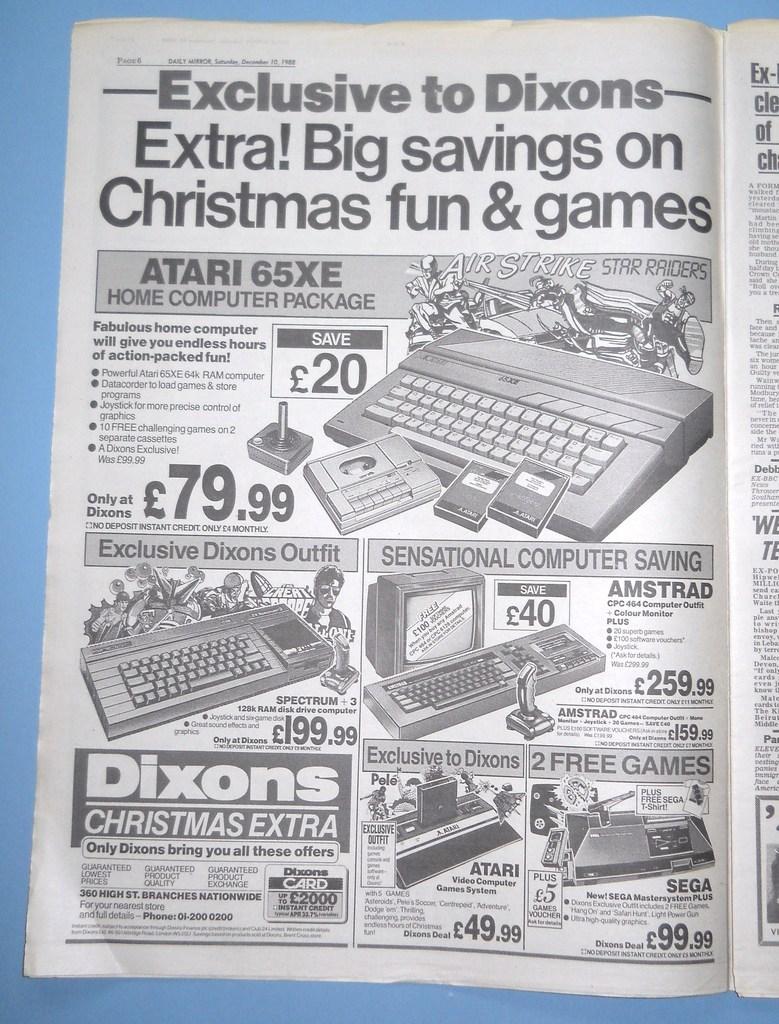What are their savings on?
Make the answer very short. Christmas fun & games. What model atari is shown in the ad?
Make the answer very short. 65xe. 